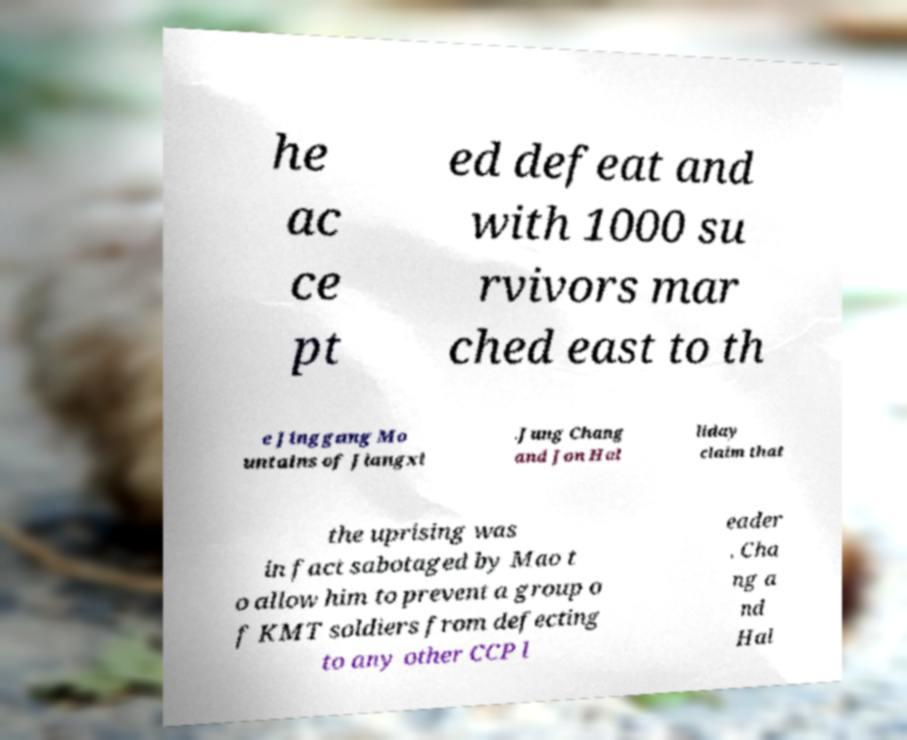There's text embedded in this image that I need extracted. Can you transcribe it verbatim? he ac ce pt ed defeat and with 1000 su rvivors mar ched east to th e Jinggang Mo untains of Jiangxi .Jung Chang and Jon Hal liday claim that the uprising was in fact sabotaged by Mao t o allow him to prevent a group o f KMT soldiers from defecting to any other CCP l eader . Cha ng a nd Hal 